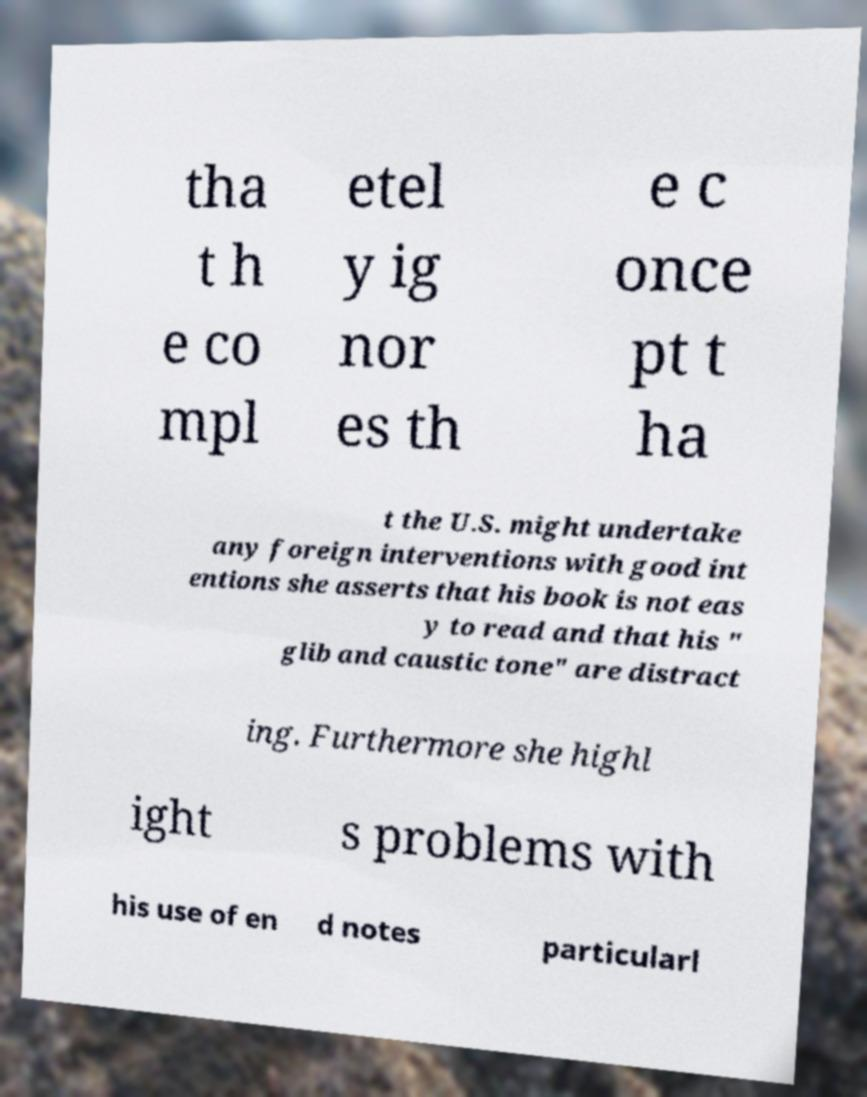I need the written content from this picture converted into text. Can you do that? tha t h e co mpl etel y ig nor es th e c once pt t ha t the U.S. might undertake any foreign interventions with good int entions she asserts that his book is not eas y to read and that his " glib and caustic tone" are distract ing. Furthermore she highl ight s problems with his use of en d notes particularl 